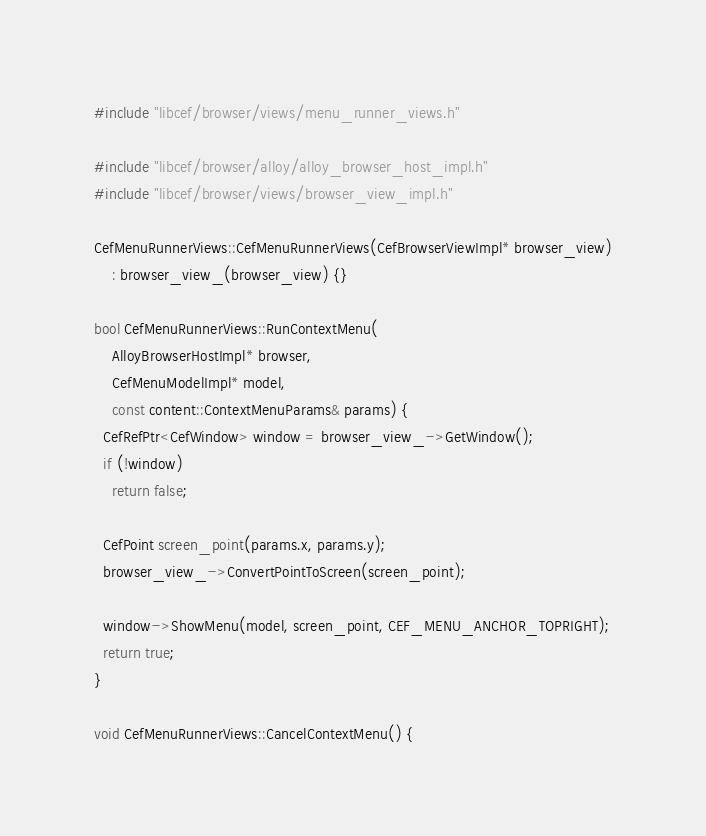<code> <loc_0><loc_0><loc_500><loc_500><_C++_>
#include "libcef/browser/views/menu_runner_views.h"

#include "libcef/browser/alloy/alloy_browser_host_impl.h"
#include "libcef/browser/views/browser_view_impl.h"

CefMenuRunnerViews::CefMenuRunnerViews(CefBrowserViewImpl* browser_view)
    : browser_view_(browser_view) {}

bool CefMenuRunnerViews::RunContextMenu(
    AlloyBrowserHostImpl* browser,
    CefMenuModelImpl* model,
    const content::ContextMenuParams& params) {
  CefRefPtr<CefWindow> window = browser_view_->GetWindow();
  if (!window)
    return false;

  CefPoint screen_point(params.x, params.y);
  browser_view_->ConvertPointToScreen(screen_point);

  window->ShowMenu(model, screen_point, CEF_MENU_ANCHOR_TOPRIGHT);
  return true;
}

void CefMenuRunnerViews::CancelContextMenu() {</code> 